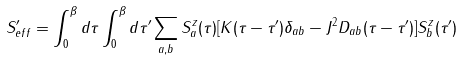<formula> <loc_0><loc_0><loc_500><loc_500>S _ { e f f } ^ { \prime } = \int _ { 0 } ^ { \beta } d \tau \int _ { 0 } ^ { \beta } d \tau ^ { \prime } \sum _ { a , b } S _ { a } ^ { z } ( \tau ) [ K ( \tau - \tau ^ { \prime } ) \delta _ { a b } - J ^ { 2 } D _ { a b } ( \tau - \tau ^ { \prime } ) ] S _ { b } ^ { z } ( \tau ^ { \prime } )</formula> 